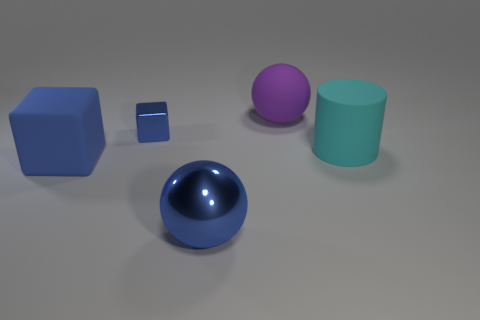Add 2 blue cubes. How many objects exist? 7 Subtract all spheres. How many objects are left? 3 Subtract all tiny metallic blocks. Subtract all tiny shiny things. How many objects are left? 3 Add 2 matte objects. How many matte objects are left? 5 Add 2 small blue metal things. How many small blue metal things exist? 3 Subtract 0 yellow spheres. How many objects are left? 5 